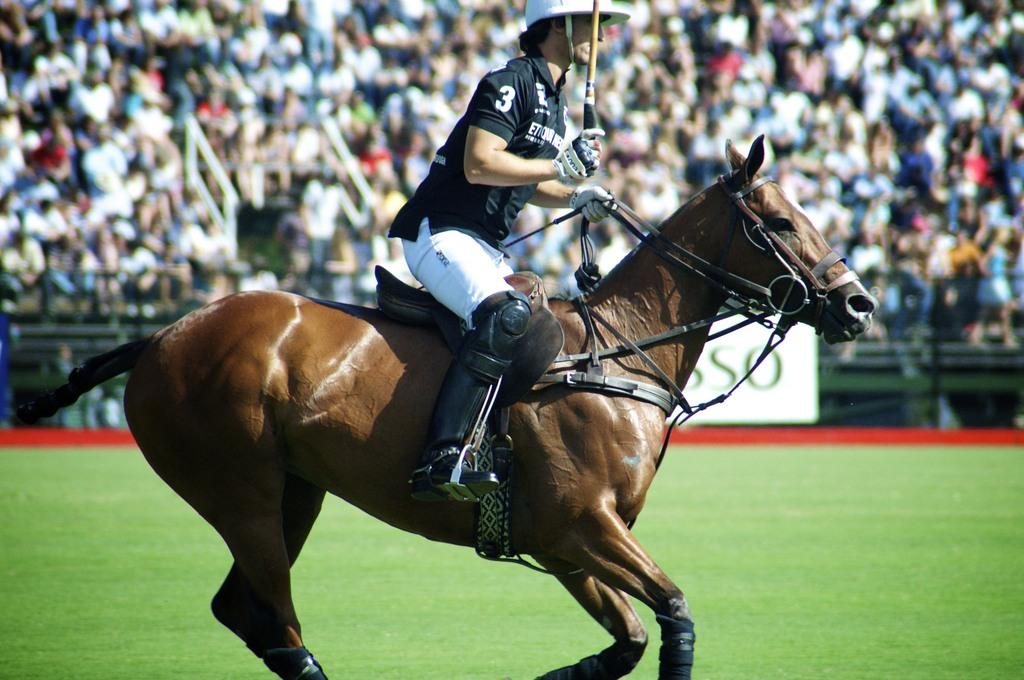What is the man doing in the image? The man is riding a horse in the image. Where is the man located in relation to the ground? The man is on the ground while riding the horse. Can you describe the setting where the man is riding the horse? There are people watching the man in a stadium. What is the sum of the love and addition in the image? There is no love or addition present in the image; it features a man riding a horse in a stadium. Can you tell me how many strings are attached to the horse in the image? There are no strings attached to the horse in the image; it is simply a man riding a horse in a stadium. 